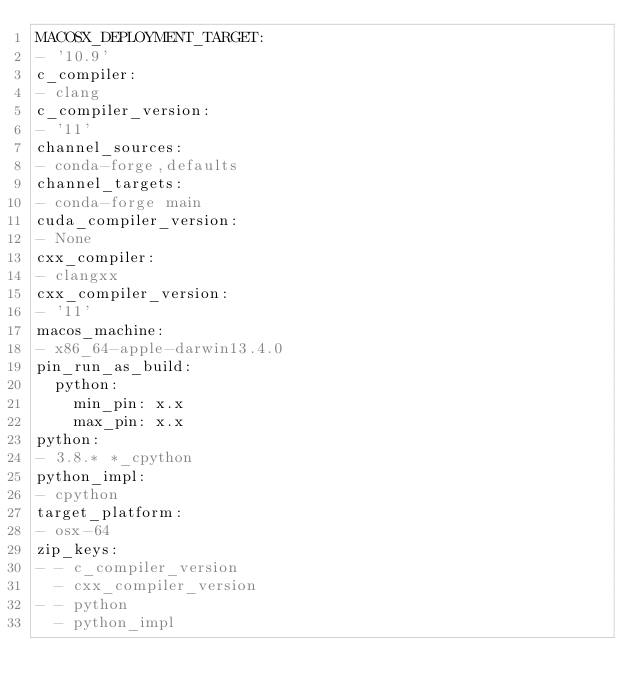Convert code to text. <code><loc_0><loc_0><loc_500><loc_500><_YAML_>MACOSX_DEPLOYMENT_TARGET:
- '10.9'
c_compiler:
- clang
c_compiler_version:
- '11'
channel_sources:
- conda-forge,defaults
channel_targets:
- conda-forge main
cuda_compiler_version:
- None
cxx_compiler:
- clangxx
cxx_compiler_version:
- '11'
macos_machine:
- x86_64-apple-darwin13.4.0
pin_run_as_build:
  python:
    min_pin: x.x
    max_pin: x.x
python:
- 3.8.* *_cpython
python_impl:
- cpython
target_platform:
- osx-64
zip_keys:
- - c_compiler_version
  - cxx_compiler_version
- - python
  - python_impl
</code> 